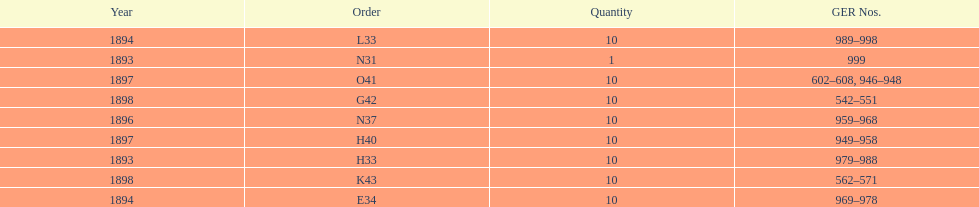What amount of time to the years span? 5 years. 